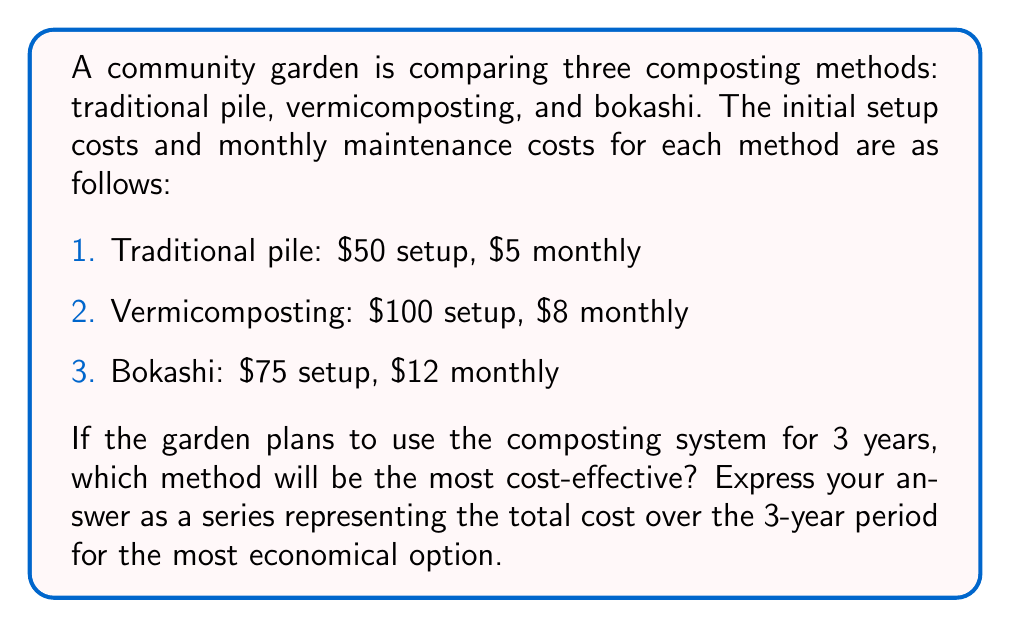Provide a solution to this math problem. To determine the most cost-effective method, we need to calculate the total cost for each composting method over the 3-year (36-month) period.

1. Traditional pile:
   Total cost = Setup cost + (Monthly cost × Number of months)
   $$ 50 + (5 \times 36) = 50 + 180 = 230 $$

2. Vermicomposting:
   $$ 100 + (8 \times 36) = 100 + 288 = 388 $$

3. Bokashi:
   $$ 75 + (12 \times 36) = 75 + 432 = 507 $$

The traditional pile method is the most cost-effective, with a total cost of $230 over 3 years.

To express this as a series, we can represent the cost as:

$$ 50 + \sum_{n=1}^{36} 5 $$

This series represents the initial setup cost of $50 plus the sum of 36 monthly payments of $5 each.
Answer: $$ 50 + \sum_{n=1}^{36} 5 $$ 